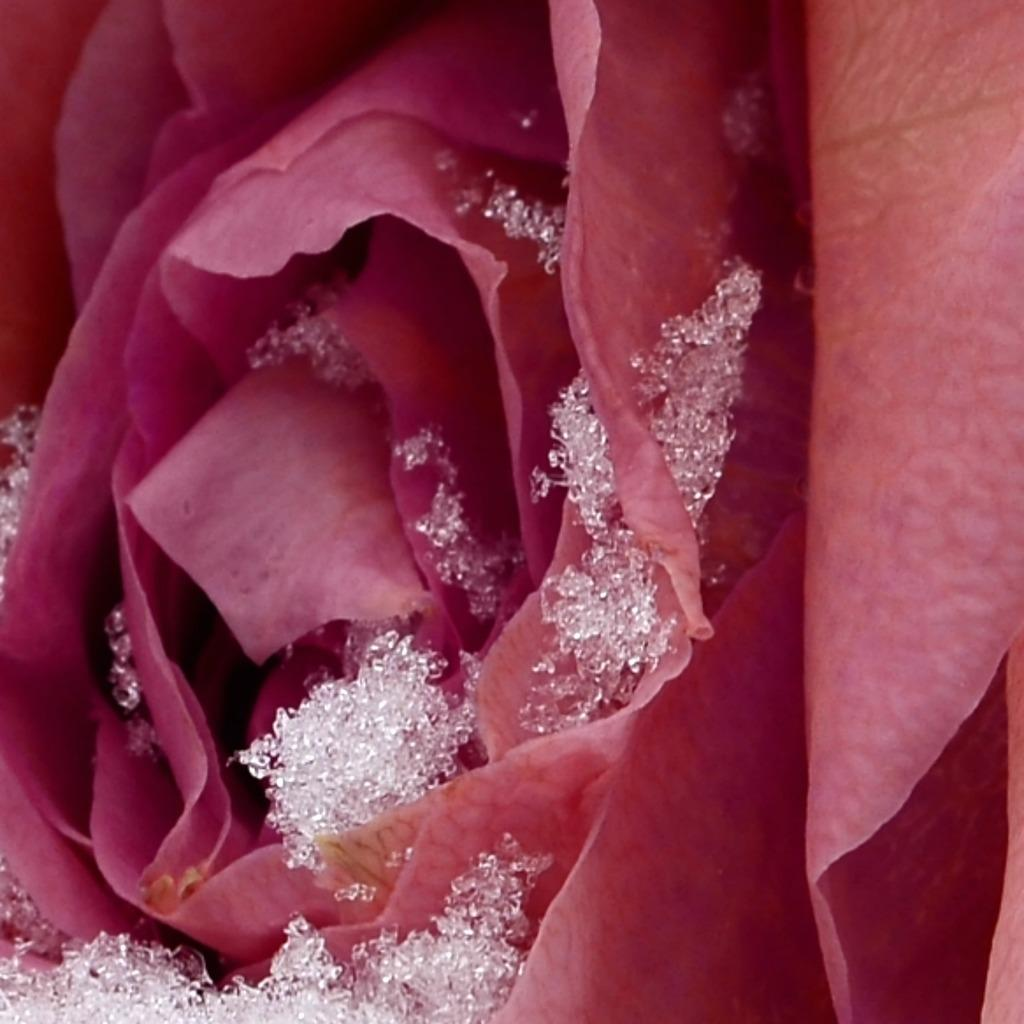What type of flower is present in the image? There is a pink color flower in the image. Can you describe any additional features on the flower? Yes, there is a white color object on the flower. How does the flower start its day in the image? The image does not provide information about how the flower starts its day. What type of wood material is visible in the image? There is no wood material present in the image. 